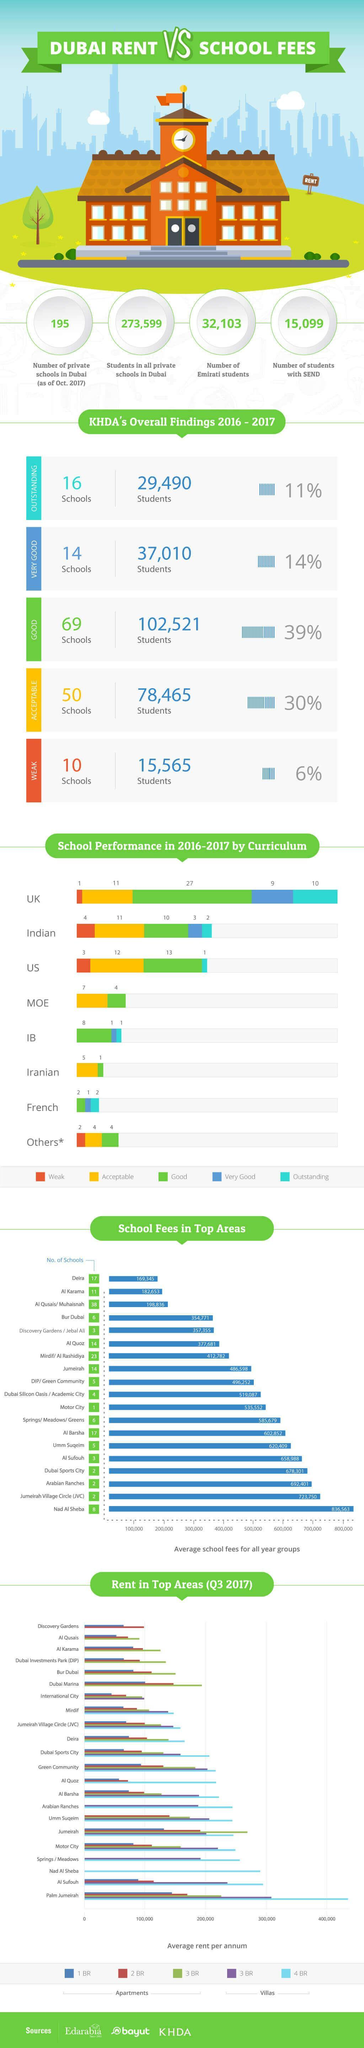Which area in Dubai costs an average rent per annum of above 400,000 AED for 4-bedroom villas in Q3 2017?
Answer the question with a short phrase. Palm Jumeirah Which area in Dubai has the highest number of schools? Al Qusais/ Muhaisnah What is the number of outstanding schools in Dubai according to the KHDA during 2016-2017? 16 Schools What percentage of the schools in Dubai were rated good according to the KHDA findings during 2016-2017? 39% What is the number of Emirati students in Dubai schools in 2017? 32,103 Which area in Dubai has the least number of schools? Motor City How many Indian schools showed an outstanding performance in the curriculum during 2016-2017? 2 How many U.S. schools showed an acceptable performance in the curriculum during 2016-2017? 12 What percentage of the schools in Dubai were rated weak according to the KHDA findings during 2016-2017? 6% What is the number of students in all private schools in Dubai in 2017? 273,599 